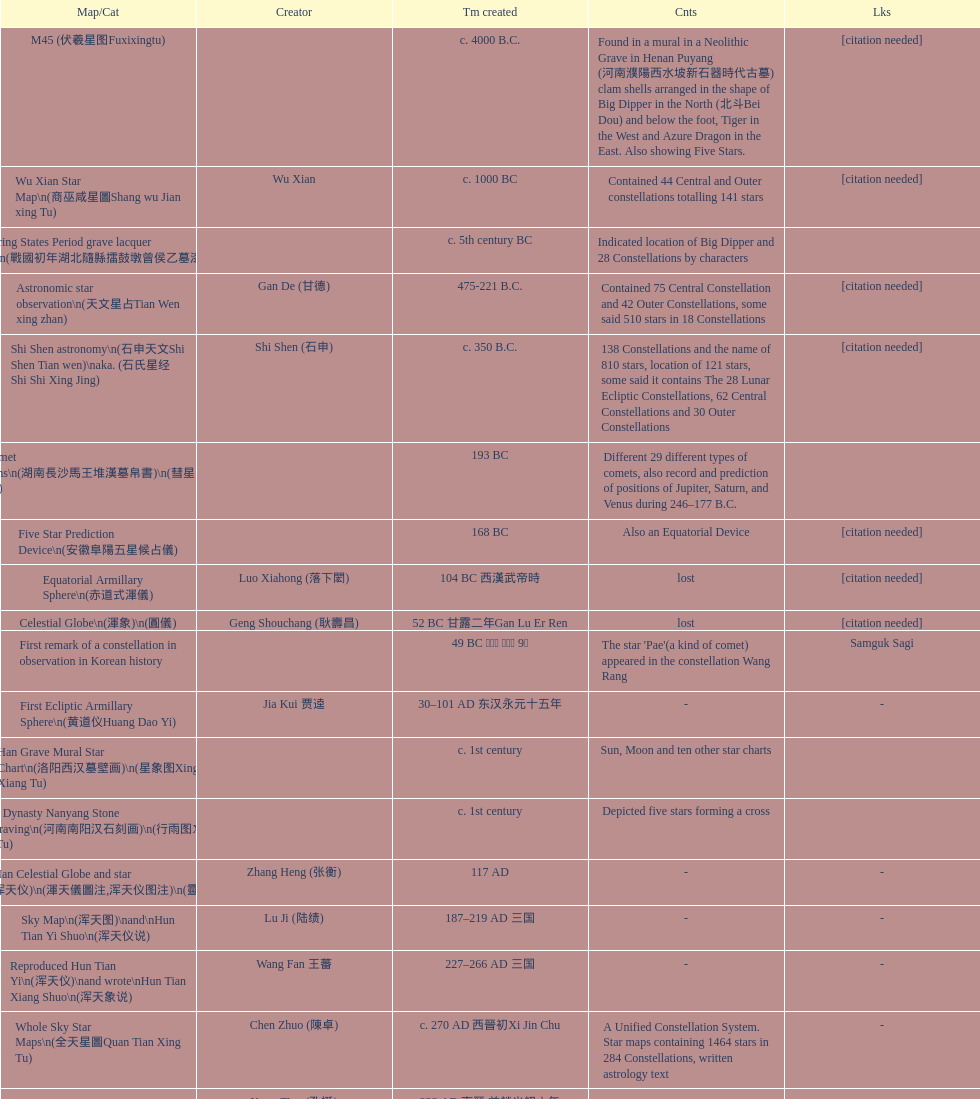Which was the first chinese star map known to have been created? M45 (伏羲星图Fuxixingtu). 